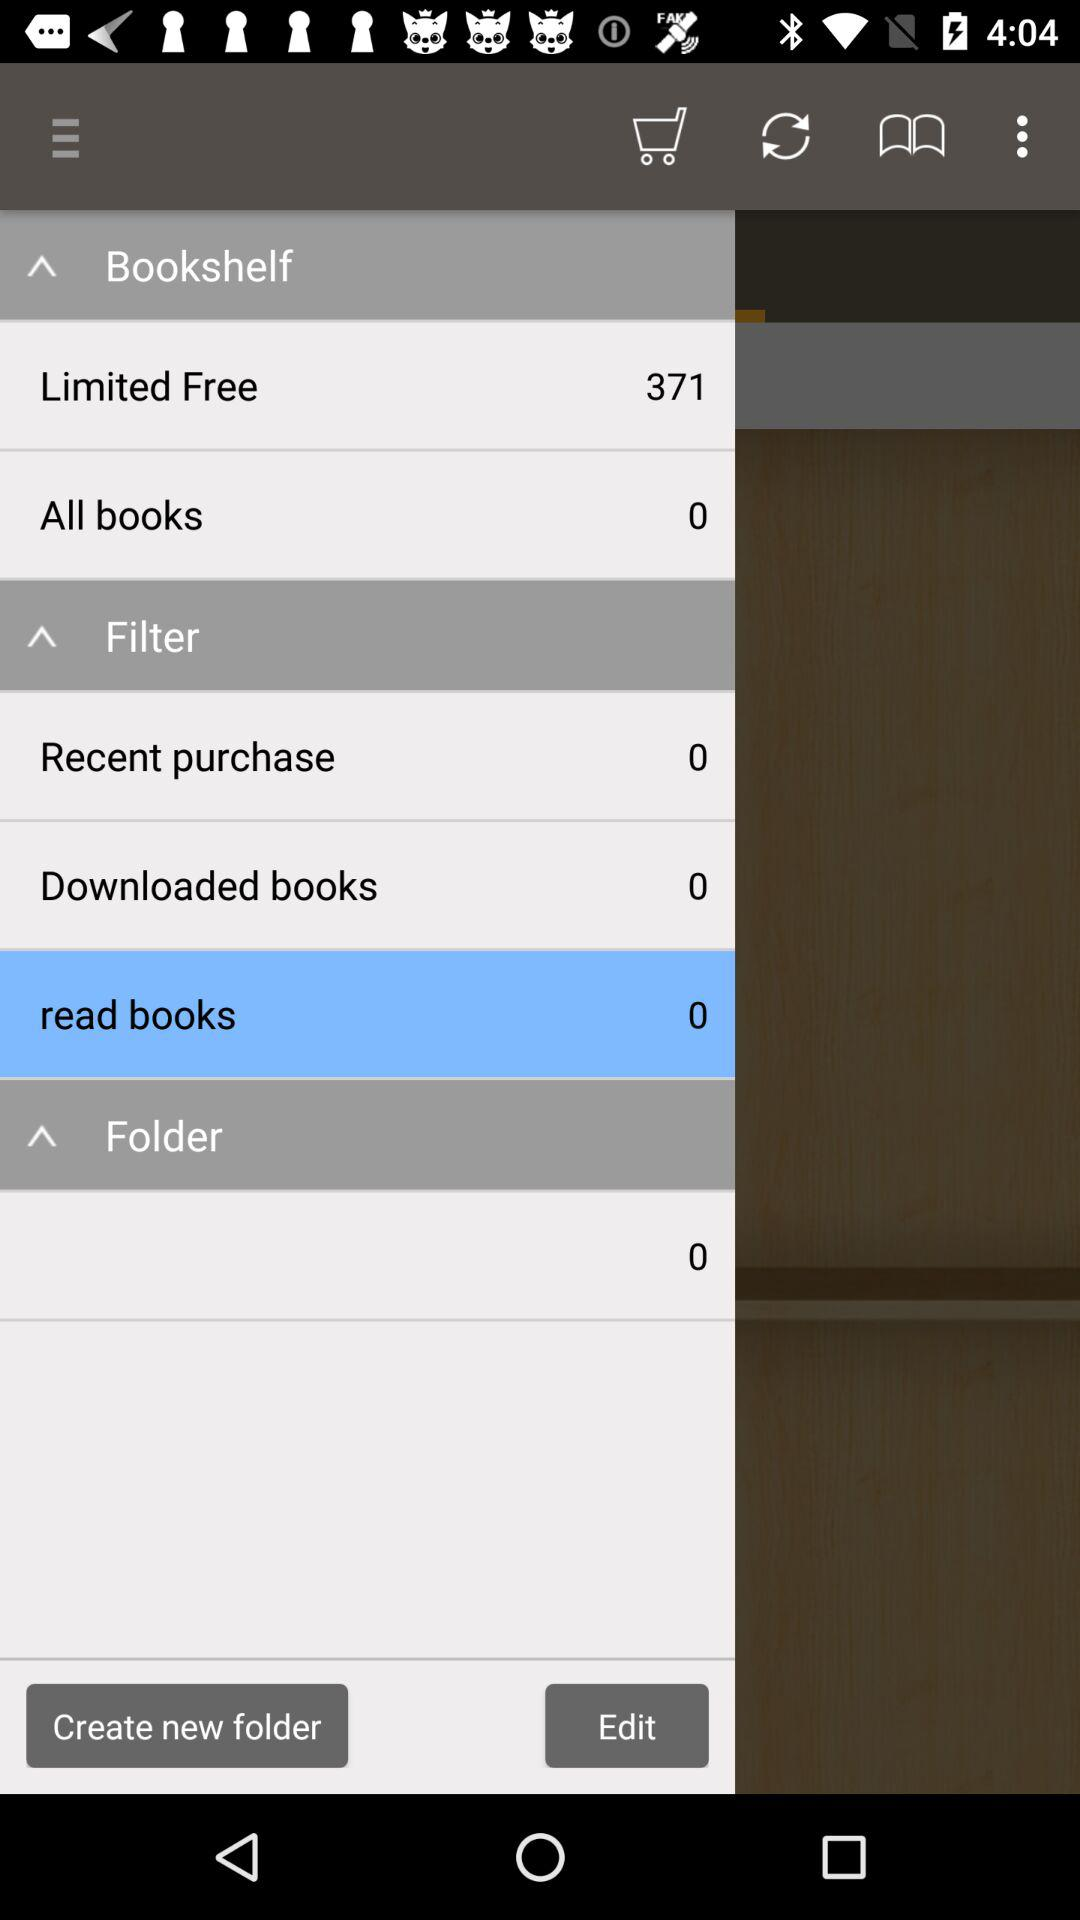How many books in total are there in "All books"? There are 0 books in total in "All books". 